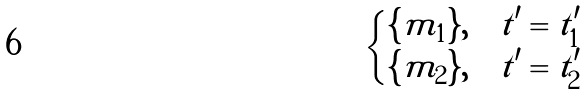<formula> <loc_0><loc_0><loc_500><loc_500>\begin{cases} \{ m _ { 1 } \} , & t ^ { \prime } = t ^ { \prime } _ { 1 } \\ \{ m _ { 2 } \} , & t ^ { \prime } = t ^ { \prime } _ { 2 } \end{cases}</formula> 